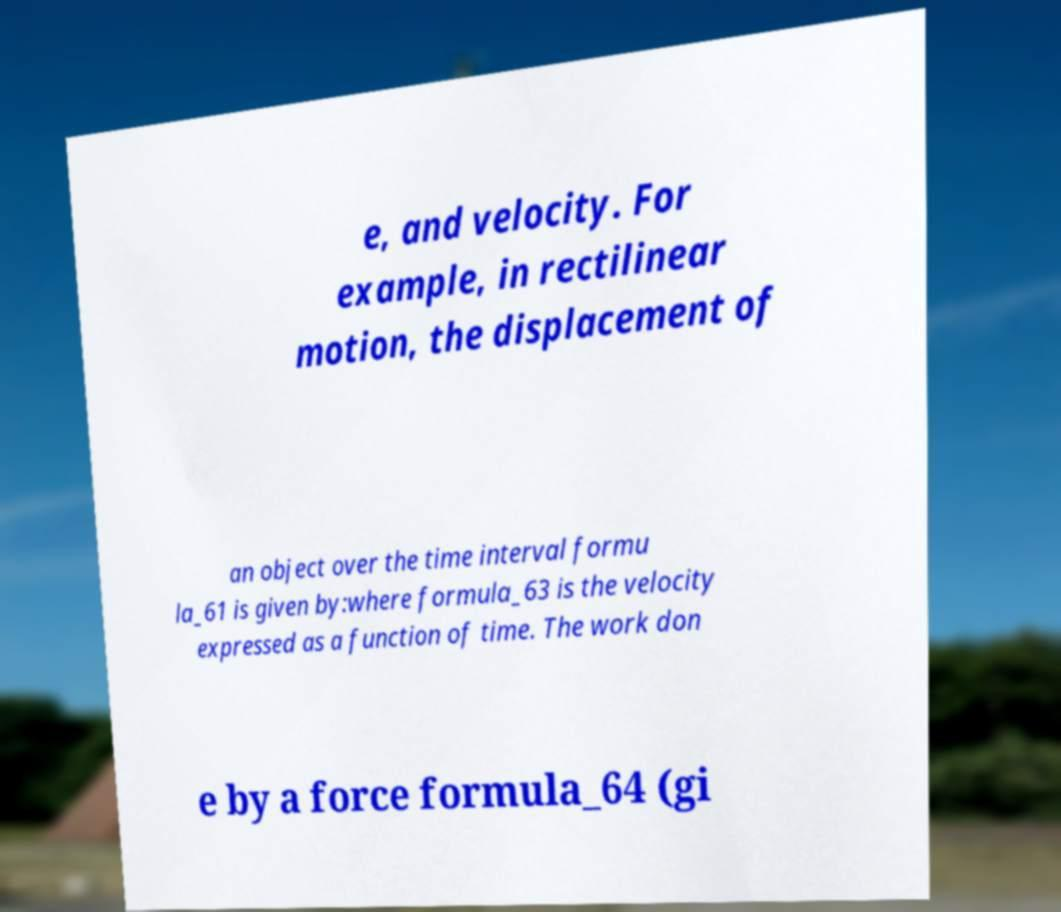Please read and relay the text visible in this image. What does it say? e, and velocity. For example, in rectilinear motion, the displacement of an object over the time interval formu la_61 is given by:where formula_63 is the velocity expressed as a function of time. The work don e by a force formula_64 (gi 